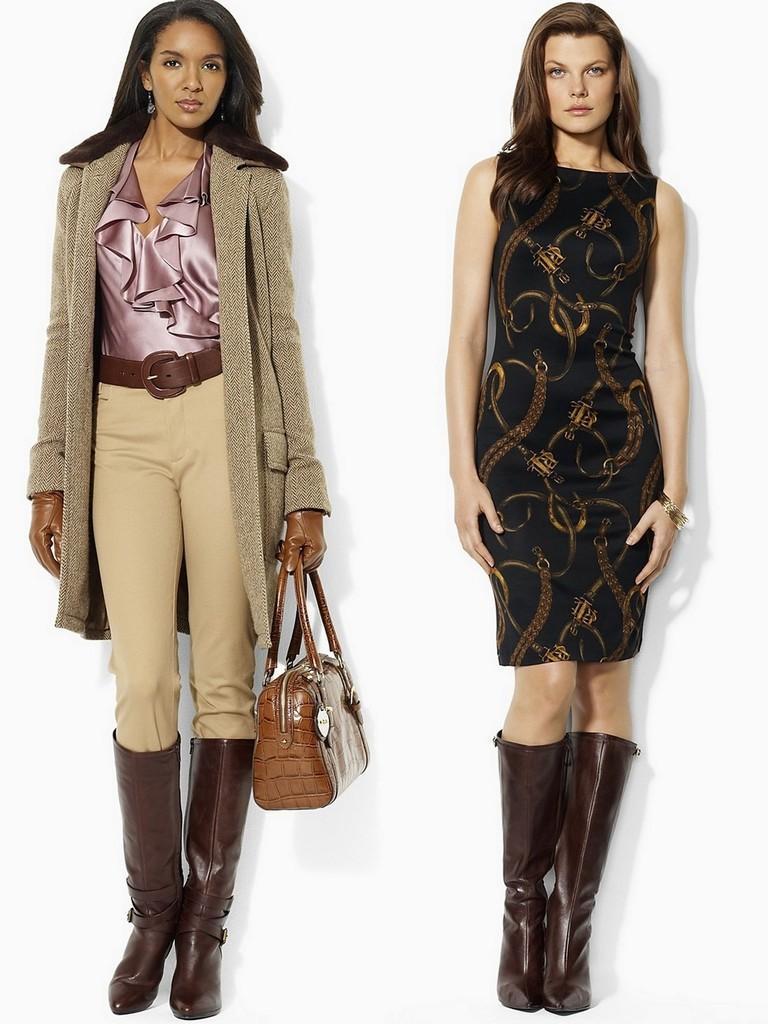In one or two sentences, can you explain what this image depicts? There are two persons in this image. Both of them are women, one is on the right side the other one is on the left side. The one who is on the left side is holding a bag. She is wearing jacket the one who is on the right side is wearing black dress. Both of them are wearing boots. 